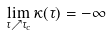<formula> <loc_0><loc_0><loc_500><loc_500>\lim _ { \tau \nearrow \tau _ { c } } \kappa ( \tau ) = - \infty</formula> 